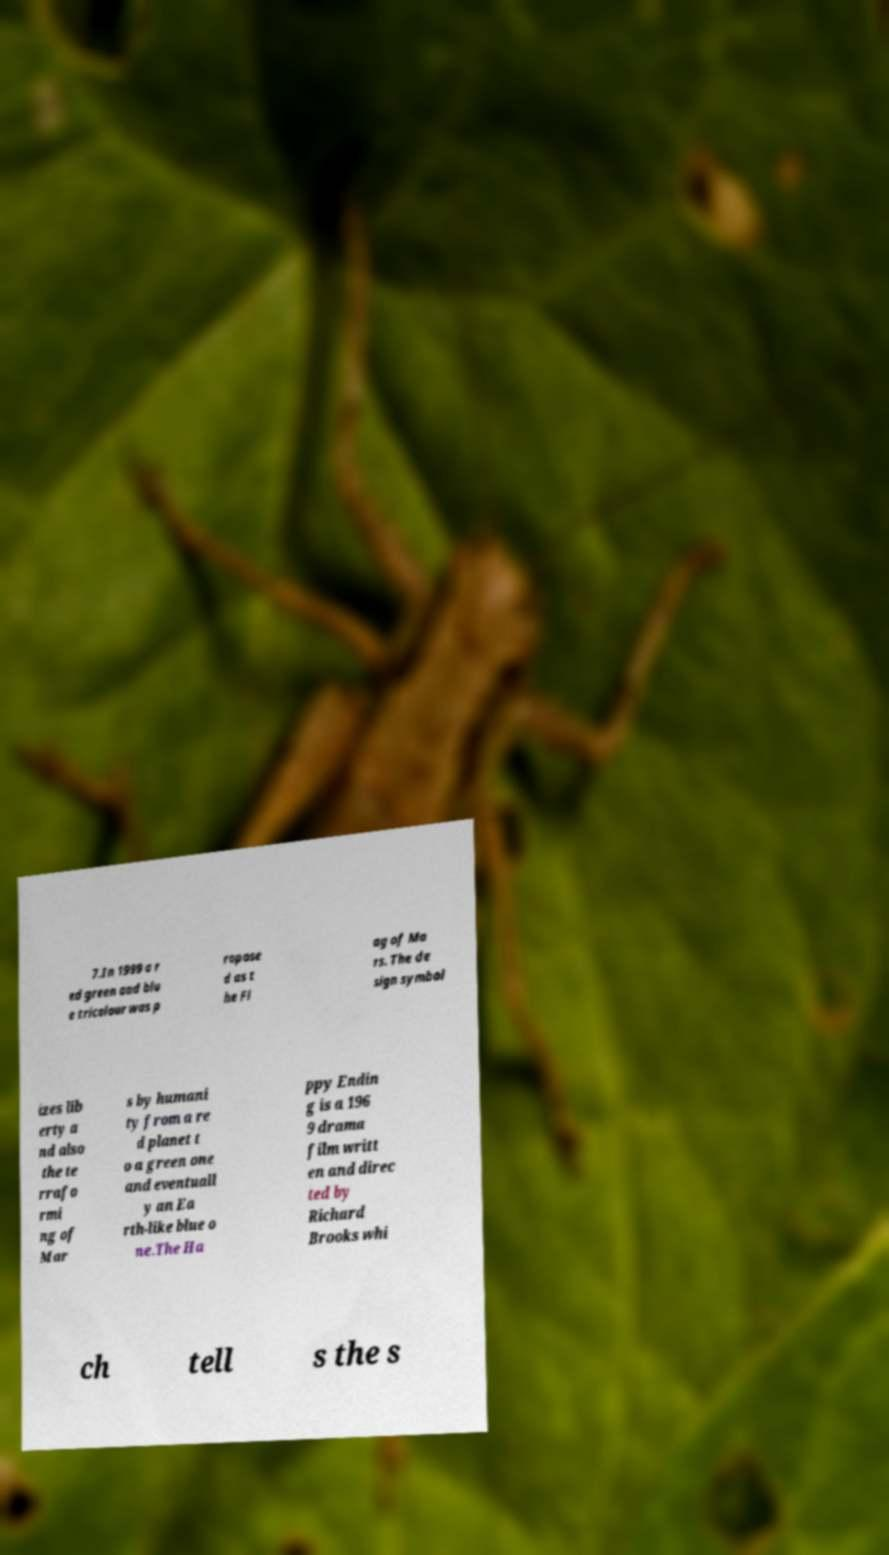Could you extract and type out the text from this image? 7.In 1999 a r ed green and blu e tricolour was p ropose d as t he Fl ag of Ma rs. The de sign symbol izes lib erty a nd also the te rrafo rmi ng of Mar s by humani ty from a re d planet t o a green one and eventuall y an Ea rth-like blue o ne.The Ha ppy Endin g is a 196 9 drama film writt en and direc ted by Richard Brooks whi ch tell s the s 